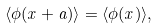Convert formula to latex. <formula><loc_0><loc_0><loc_500><loc_500>\langle \phi ( x + a ) \rangle = \langle \phi ( x ) \rangle ,</formula> 